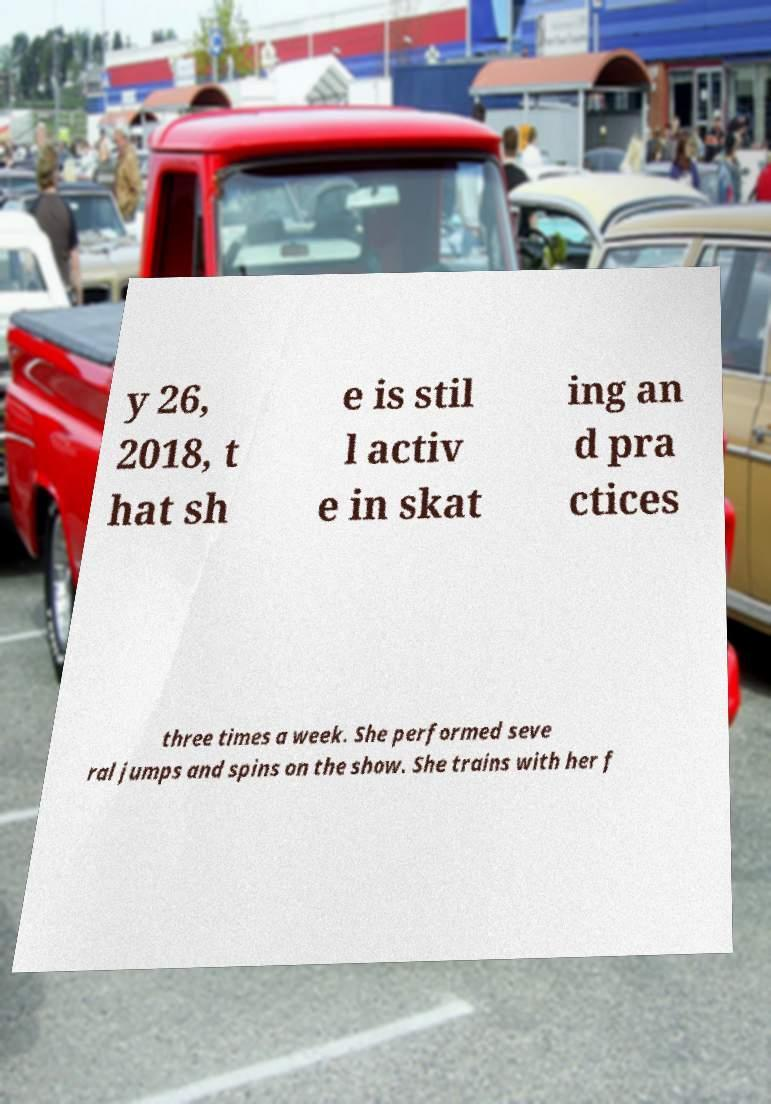Please identify and transcribe the text found in this image. y 26, 2018, t hat sh e is stil l activ e in skat ing an d pra ctices three times a week. She performed seve ral jumps and spins on the show. She trains with her f 